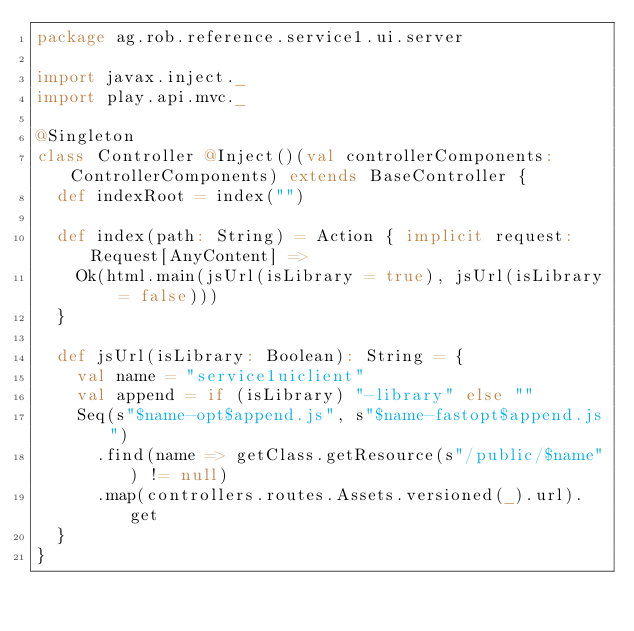Convert code to text. <code><loc_0><loc_0><loc_500><loc_500><_Scala_>package ag.rob.reference.service1.ui.server

import javax.inject._
import play.api.mvc._

@Singleton
class Controller @Inject()(val controllerComponents: ControllerComponents) extends BaseController {
  def indexRoot = index("")

  def index(path: String) = Action { implicit request: Request[AnyContent] =>
    Ok(html.main(jsUrl(isLibrary = true), jsUrl(isLibrary = false)))
  }

  def jsUrl(isLibrary: Boolean): String = {
    val name = "service1uiclient"
    val append = if (isLibrary) "-library" else ""
    Seq(s"$name-opt$append.js", s"$name-fastopt$append.js")
      .find(name => getClass.getResource(s"/public/$name") != null)
      .map(controllers.routes.Assets.versioned(_).url).get
  }
}
</code> 